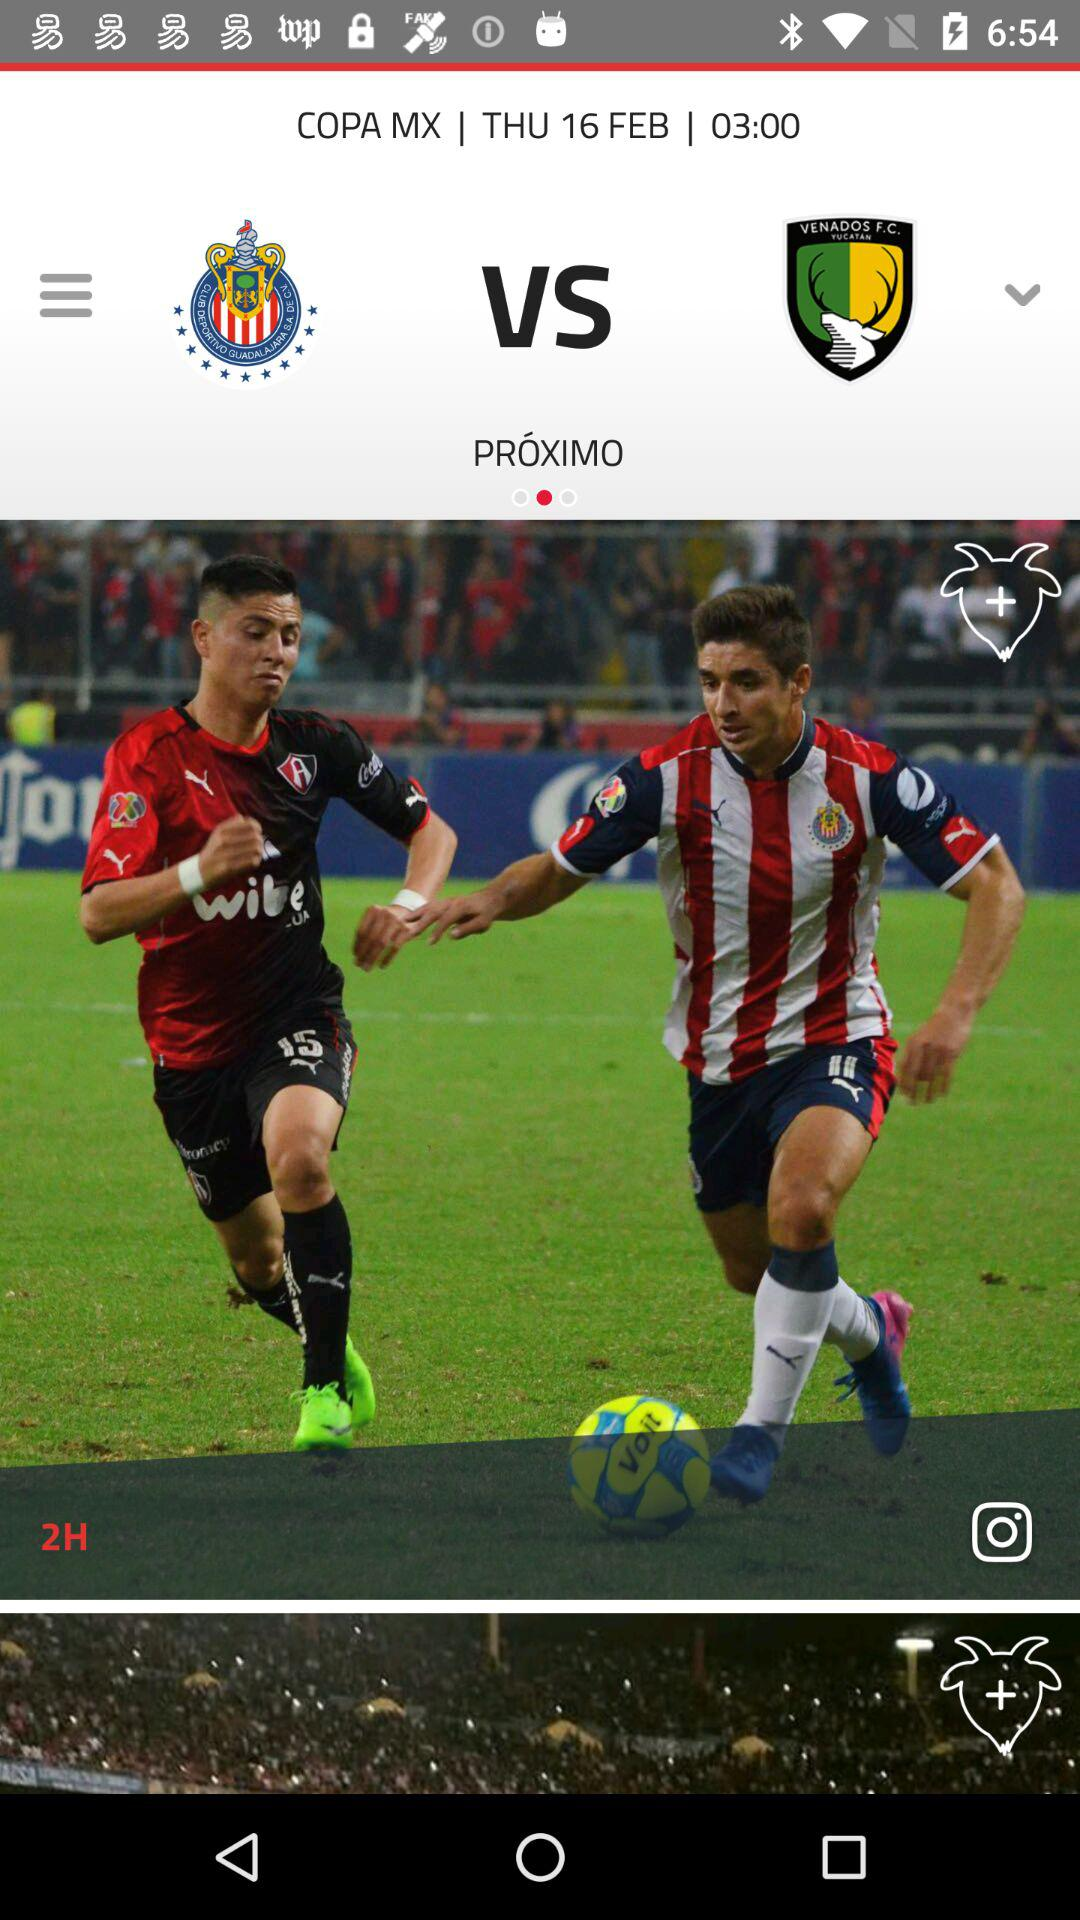How many teams are playing in the game? 2 